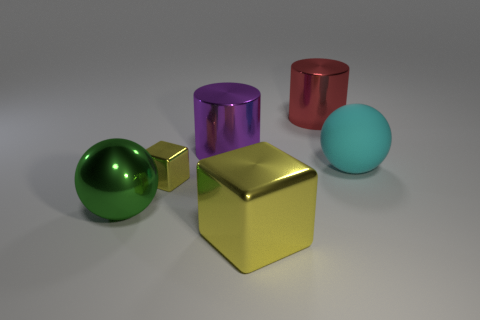There is another block that is the same color as the big shiny block; what size is it?
Make the answer very short. Small. There is a big sphere that is to the right of the ball that is in front of the cyan ball; what is its material?
Keep it short and to the point. Rubber. The large thing that is to the left of the big yellow metallic object and in front of the purple shiny thing has what shape?
Provide a succinct answer. Sphere. What size is the other thing that is the same shape as the tiny thing?
Your answer should be compact. Large. Is the number of red metal cylinders that are left of the large matte object less than the number of blue matte things?
Ensure brevity in your answer.  No. What size is the metal block that is in front of the large shiny sphere?
Your answer should be compact. Large. What is the color of the big object that is the same shape as the tiny yellow thing?
Your answer should be very brief. Yellow. How many other shiny things have the same color as the tiny thing?
Make the answer very short. 1. Is there a block that is left of the metallic object in front of the big ball that is in front of the big rubber object?
Provide a succinct answer. Yes. What number of large purple balls are the same material as the big purple cylinder?
Keep it short and to the point. 0. 